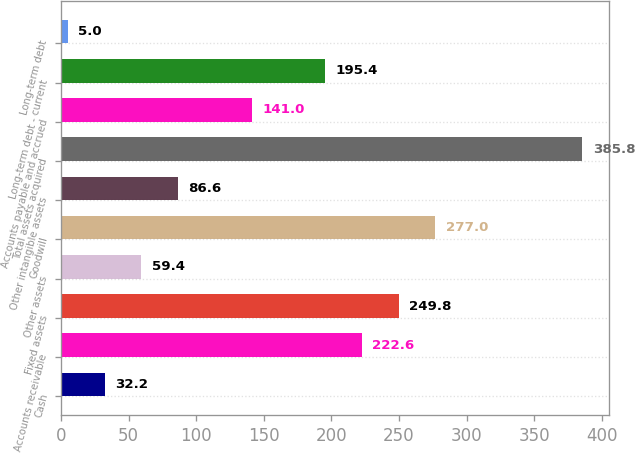Convert chart to OTSL. <chart><loc_0><loc_0><loc_500><loc_500><bar_chart><fcel>Cash<fcel>Accounts receivable<fcel>Fixed assets<fcel>Other assets<fcel>Goodwill<fcel>Other intangible assets<fcel>Total assets acquired<fcel>Accounts payable and accrued<fcel>Long-term debt - current<fcel>Long-term debt<nl><fcel>32.2<fcel>222.6<fcel>249.8<fcel>59.4<fcel>277<fcel>86.6<fcel>385.8<fcel>141<fcel>195.4<fcel>5<nl></chart> 